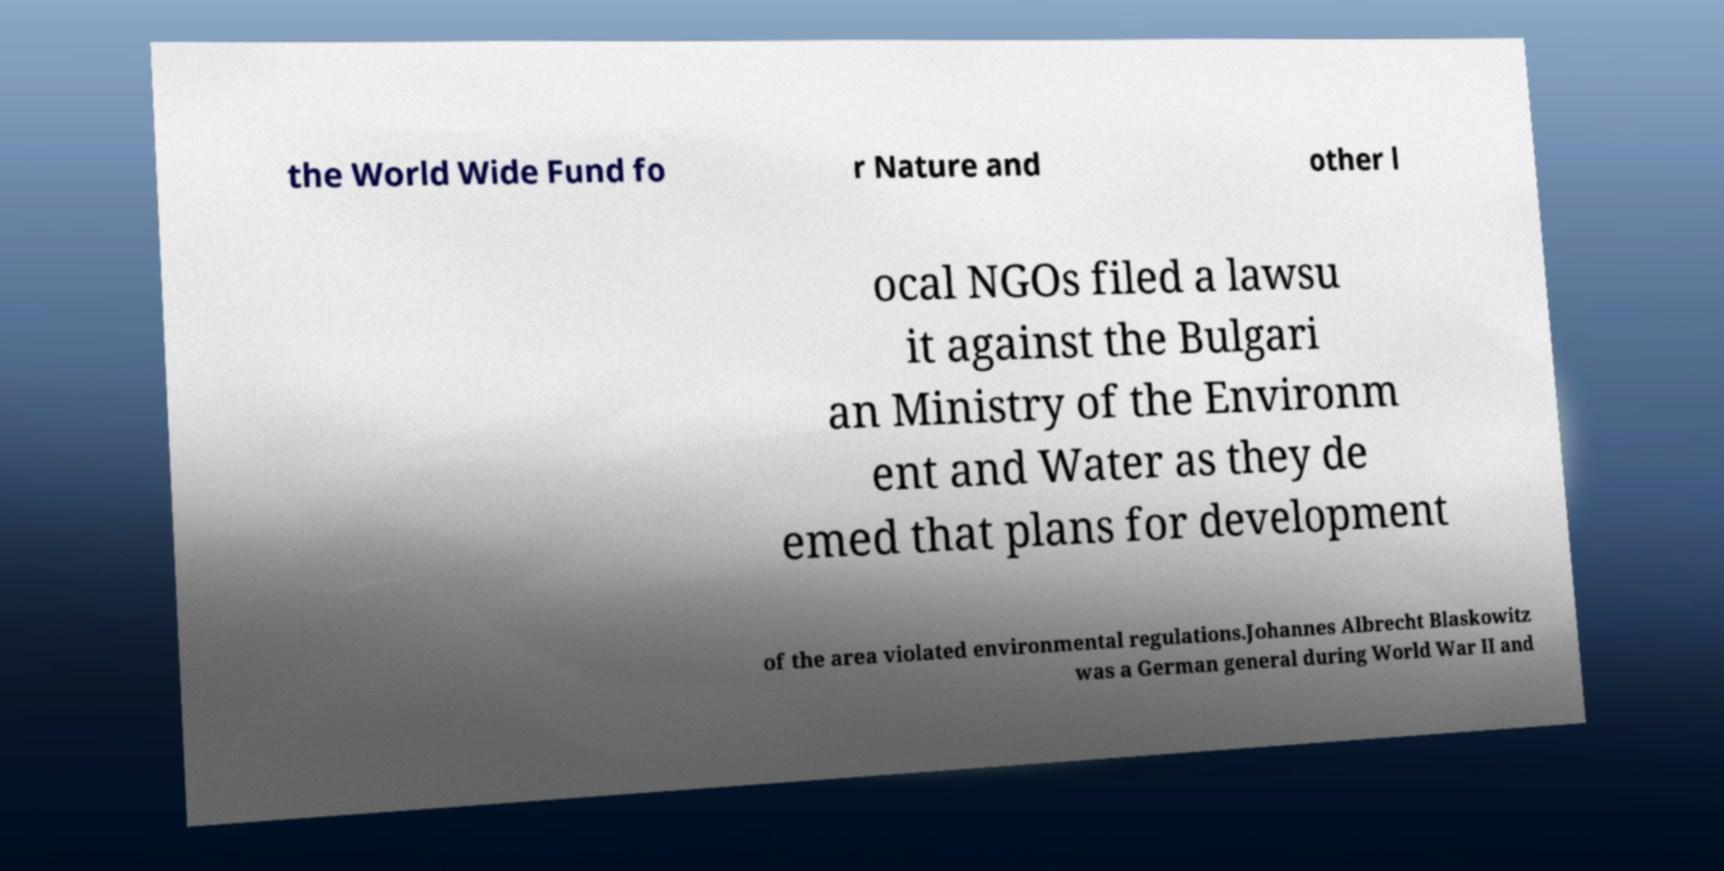What messages or text are displayed in this image? I need them in a readable, typed format. the World Wide Fund fo r Nature and other l ocal NGOs filed a lawsu it against the Bulgari an Ministry of the Environm ent and Water as they de emed that plans for development of the area violated environmental regulations.Johannes Albrecht Blaskowitz was a German general during World War II and 